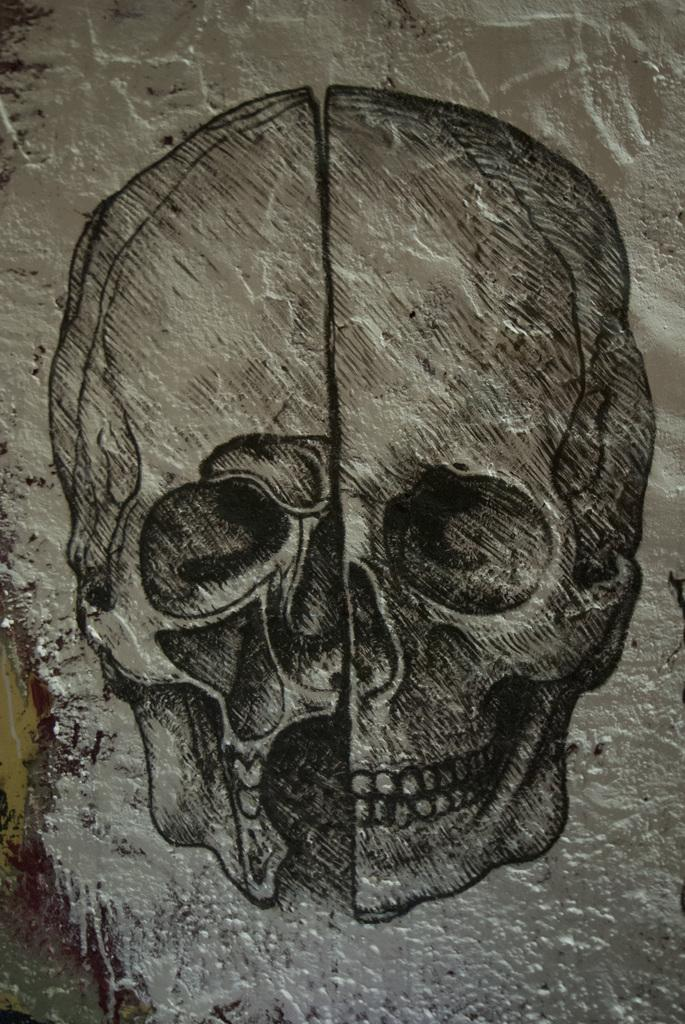What is depicted in the painting that is visible in the image? There is a painting of a human skull in the image. Where is the painting located? The painting is on a wall. What type of leather is used to make the minister's shoes in the image? There is no minister or leather shoes present in the image; it only features a painting of a human skull on a wall. 